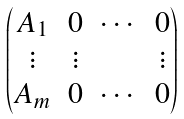<formula> <loc_0><loc_0><loc_500><loc_500>\begin{pmatrix} A _ { 1 } & 0 & \cdots & 0 \\ \vdots & \vdots & \ & \vdots \\ A _ { m } & 0 & \cdots & 0 \end{pmatrix}</formula> 